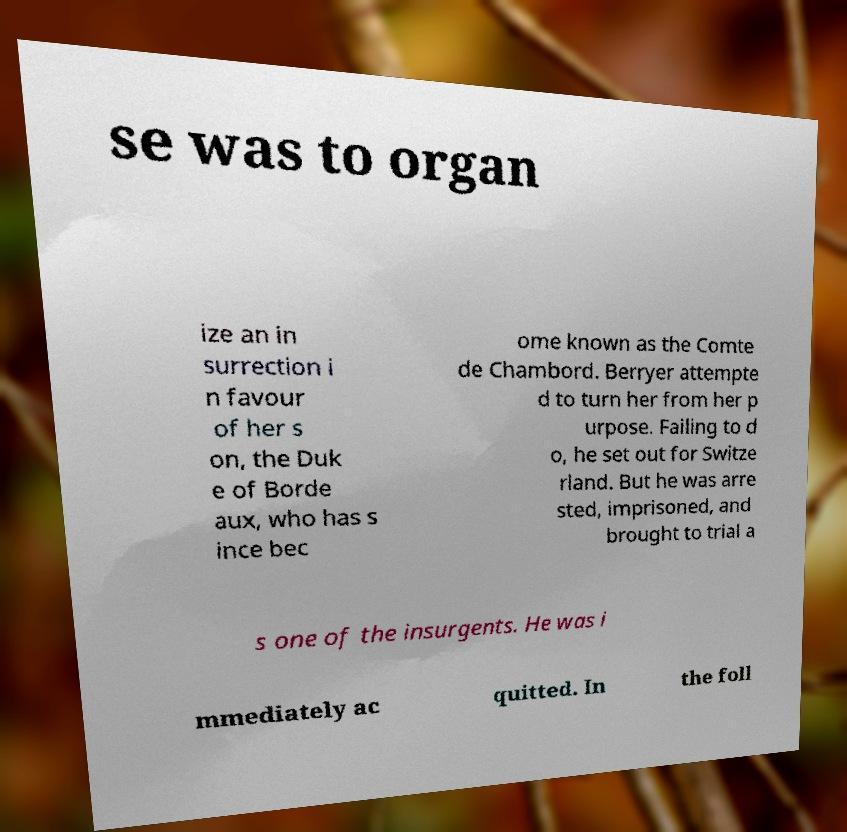Can you read and provide the text displayed in the image?This photo seems to have some interesting text. Can you extract and type it out for me? se was to organ ize an in surrection i n favour of her s on, the Duk e of Borde aux, who has s ince bec ome known as the Comte de Chambord. Berryer attempte d to turn her from her p urpose. Failing to d o, he set out for Switze rland. But he was arre sted, imprisoned, and brought to trial a s one of the insurgents. He was i mmediately ac quitted. In the foll 